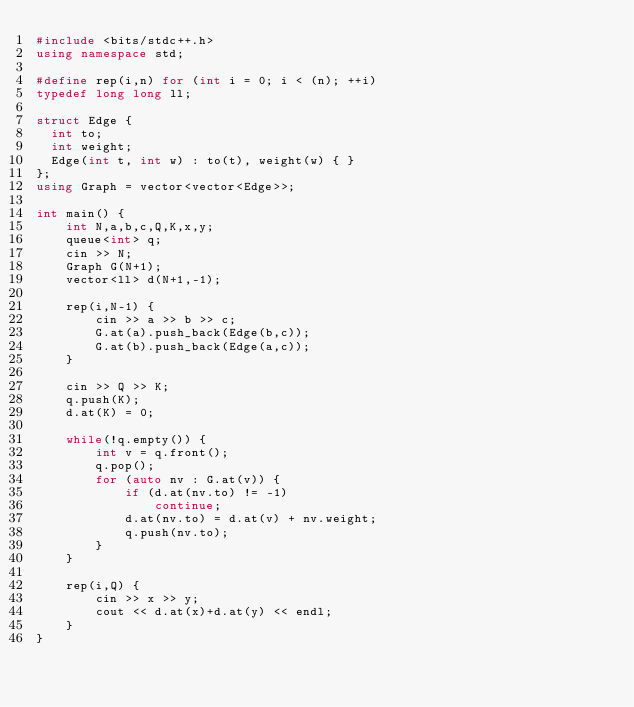<code> <loc_0><loc_0><loc_500><loc_500><_C++_>#include <bits/stdc++.h>
using namespace std;

#define rep(i,n) for (int i = 0; i < (n); ++i)
typedef long long ll;

struct Edge {
  int to;
  int weight;
  Edge(int t, int w) : to(t), weight(w) { }
};
using Graph = vector<vector<Edge>>;

int main() {
    int N,a,b,c,Q,K,x,y;
    queue<int> q;
    cin >> N;
    Graph G(N+1);
    vector<ll> d(N+1,-1);

    rep(i,N-1) {
        cin >> a >> b >> c;
        G.at(a).push_back(Edge(b,c));
        G.at(b).push_back(Edge(a,c));
    }

    cin >> Q >> K;
    q.push(K);
    d.at(K) = 0;

    while(!q.empty()) {
        int v = q.front();
        q.pop();
        for (auto nv : G.at(v)) {
            if (d.at(nv.to) != -1)
                continue;
            d.at(nv.to) = d.at(v) + nv.weight;
            q.push(nv.to);
        }
    }
    
    rep(i,Q) {
        cin >> x >> y;
        cout << d.at(x)+d.at(y) << endl;
    }
}</code> 